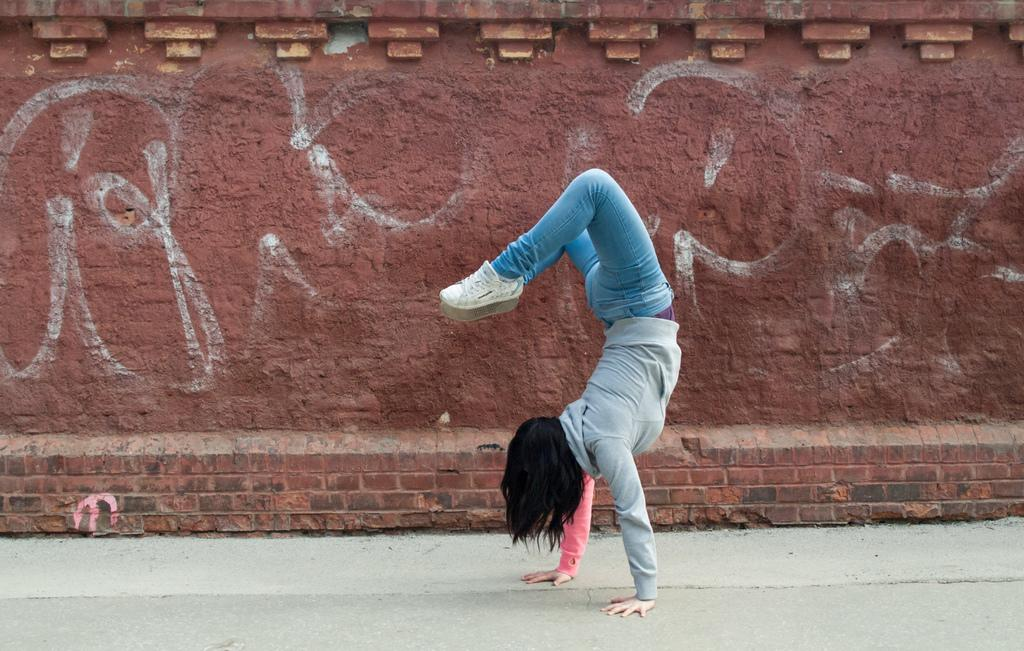What is happening in the image? There is a person in the image doing some exercise. Where is the exercise taking place? The exercise is taking place on the road. What can be seen behind the person? There is a wall visible behind the person. What type of letter is the goat reading for pleasure in the image? There is no goat or letter present in the image, and therefore no such activity can be observed. 